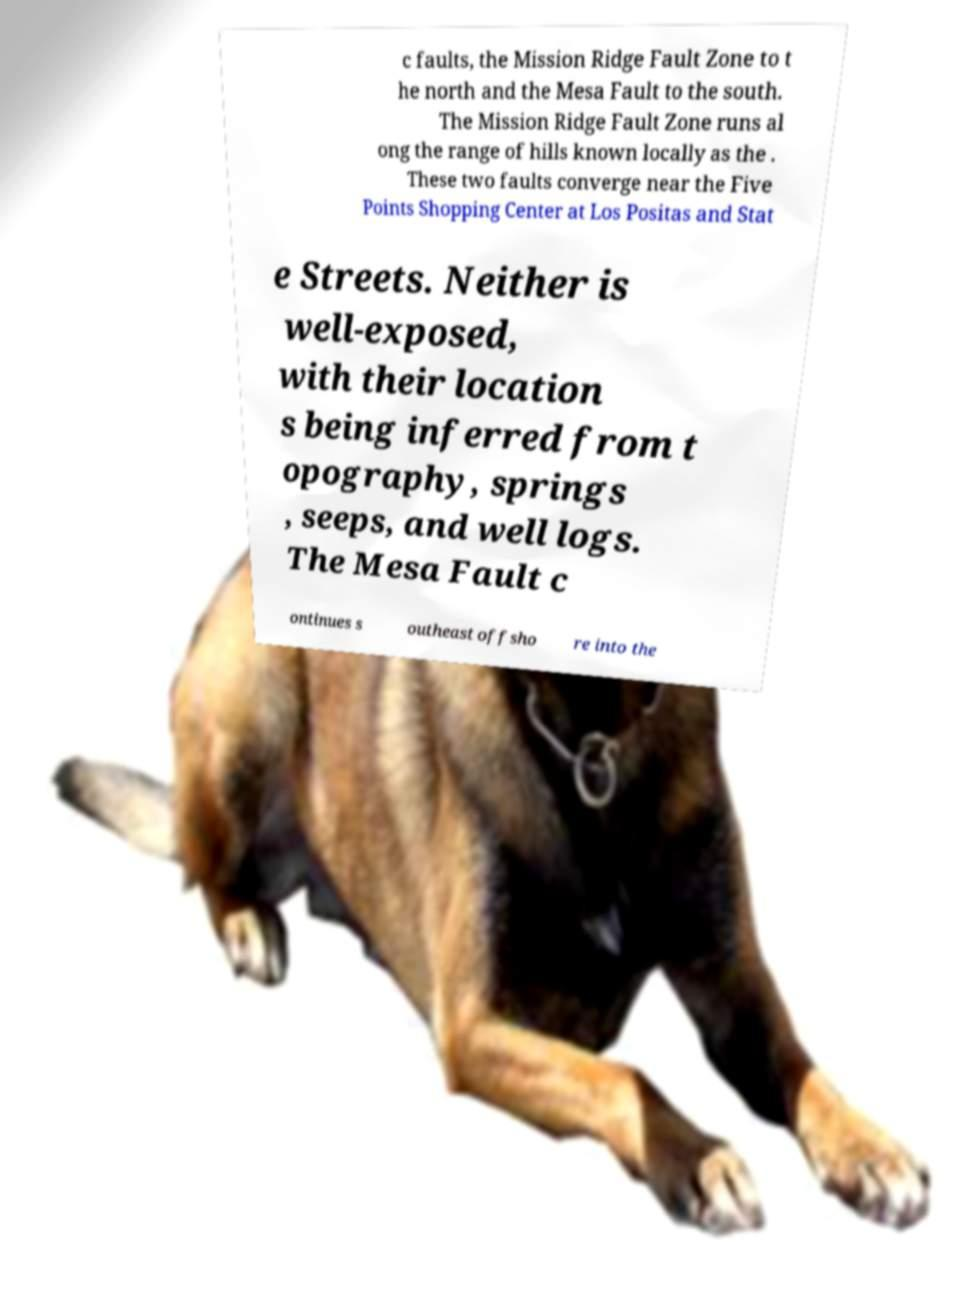Please identify and transcribe the text found in this image. c faults, the Mission Ridge Fault Zone to t he north and the Mesa Fault to the south. The Mission Ridge Fault Zone runs al ong the range of hills known locally as the . These two faults converge near the Five Points Shopping Center at Los Positas and Stat e Streets. Neither is well-exposed, with their location s being inferred from t opography, springs , seeps, and well logs. The Mesa Fault c ontinues s outheast offsho re into the 